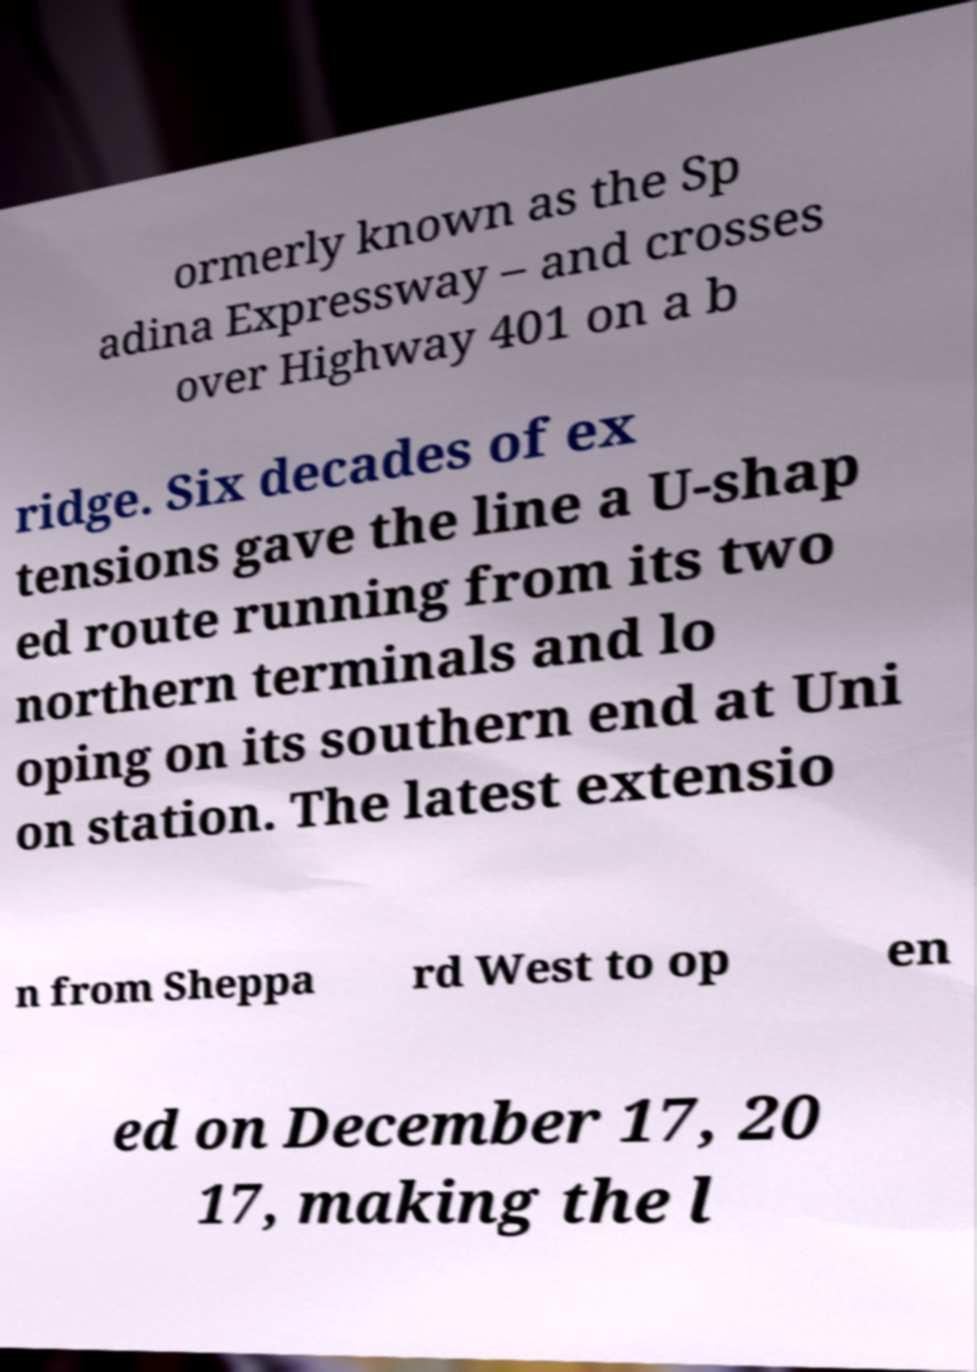Can you read and provide the text displayed in the image?This photo seems to have some interesting text. Can you extract and type it out for me? ormerly known as the Sp adina Expressway – and crosses over Highway 401 on a b ridge. Six decades of ex tensions gave the line a U-shap ed route running from its two northern terminals and lo oping on its southern end at Uni on station. The latest extensio n from Sheppa rd West to op en ed on December 17, 20 17, making the l 